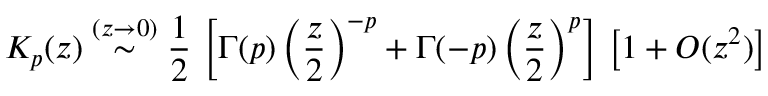Convert formula to latex. <formula><loc_0><loc_0><loc_500><loc_500>K _ { p } ( z ) \stackrel { ( z \rightarrow 0 ) } { \sim } \frac { 1 } { 2 } \, \left [ \Gamma ( p ) \left ( \frac { z } { 2 } \right ) ^ { - p } + \Gamma ( - p ) \left ( \frac { z } { 2 } \right ) ^ { p } \right ] \, \left [ 1 + O ( z ^ { 2 } ) \right ] \,</formula> 